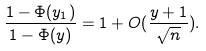<formula> <loc_0><loc_0><loc_500><loc_500>\frac { 1 - \Phi ( y _ { 1 } ) } { 1 - \Phi ( y ) } = 1 + O ( \frac { y + 1 } { \sqrt { n } } ) .</formula> 